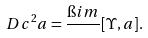<formula> <loc_0><loc_0><loc_500><loc_500>\ D c ^ { 2 } a = \frac { \i i m } { } [ \Upsilon , a ] .</formula> 